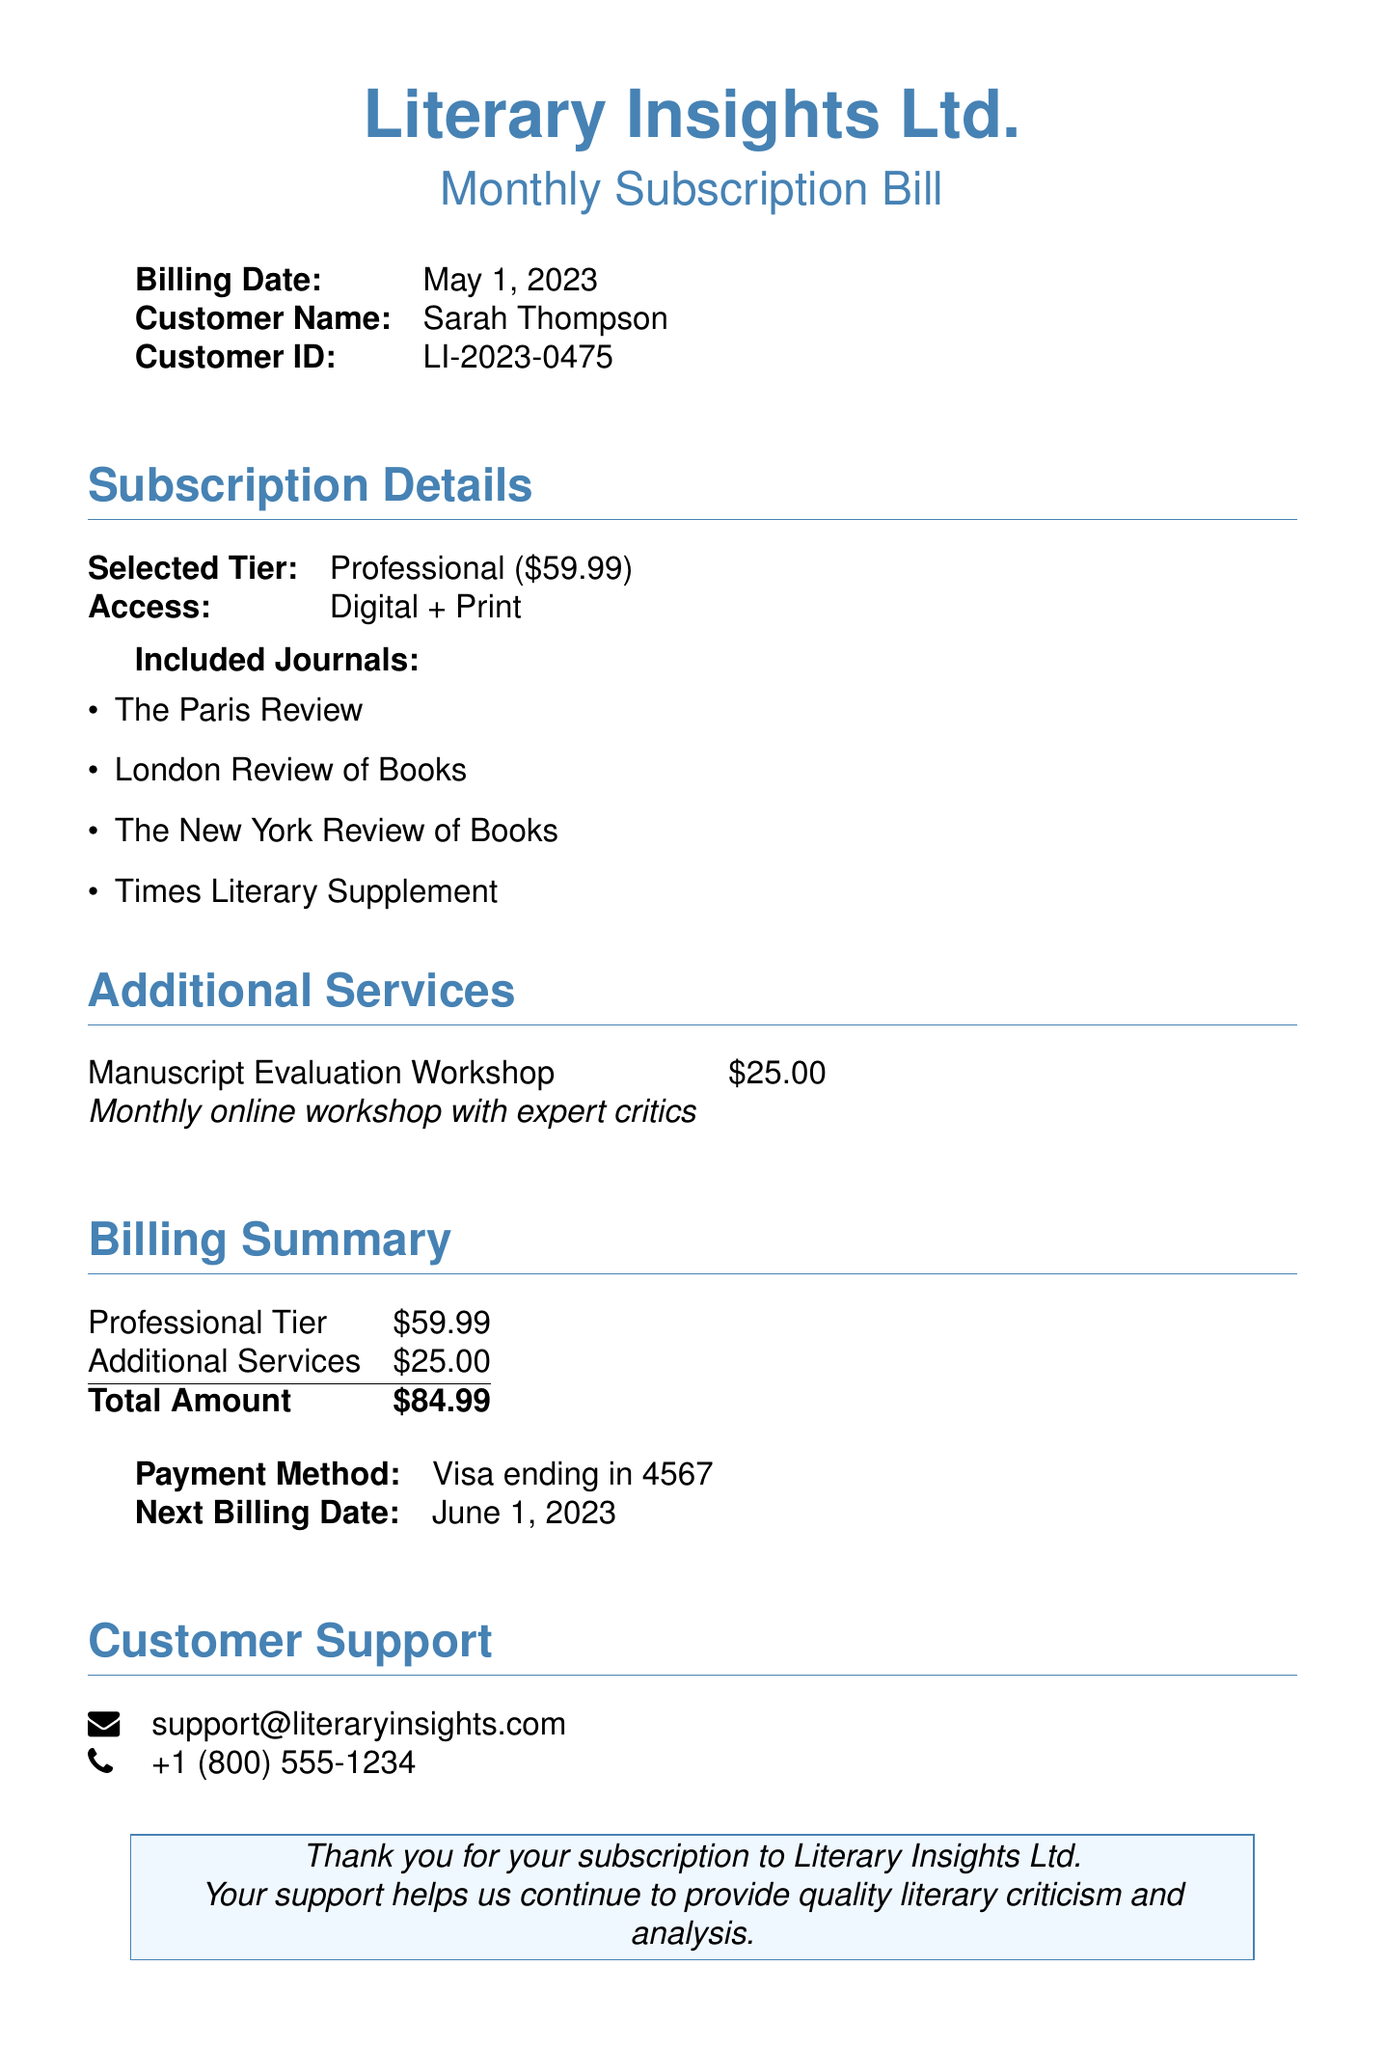What is the billing date? The billing date is specified in the document, which is May 1, 2023.
Answer: May 1, 2023 Who is the customer? The document specifies the customer name as Sarah Thompson.
Answer: Sarah Thompson What is the total amount due? The total amount is calculated from the subscription and additional services, which is $84.99.
Answer: $84.99 What type of access is provided in the selected tier? The selected tier grants specific access, which is Digital + Print.
Answer: Digital + Print What additional service is offered? The document lists only one additional service, which is a Manuscript Evaluation Workshop.
Answer: Manuscript Evaluation Workshop How much does the Professional tier cost? The cost of the Professional tier is stated as $59.99.
Answer: $59.99 What is the next billing date? The next billing date is mentioned as June 1, 2023.
Answer: June 1, 2023 What payment method was used? The document indicates the payment method as Visa.
Answer: Visa What is the email address for customer support? The email for customer support is provided in the contact information section as support@literaryinsights.com.
Answer: support@literaryinsights.com 